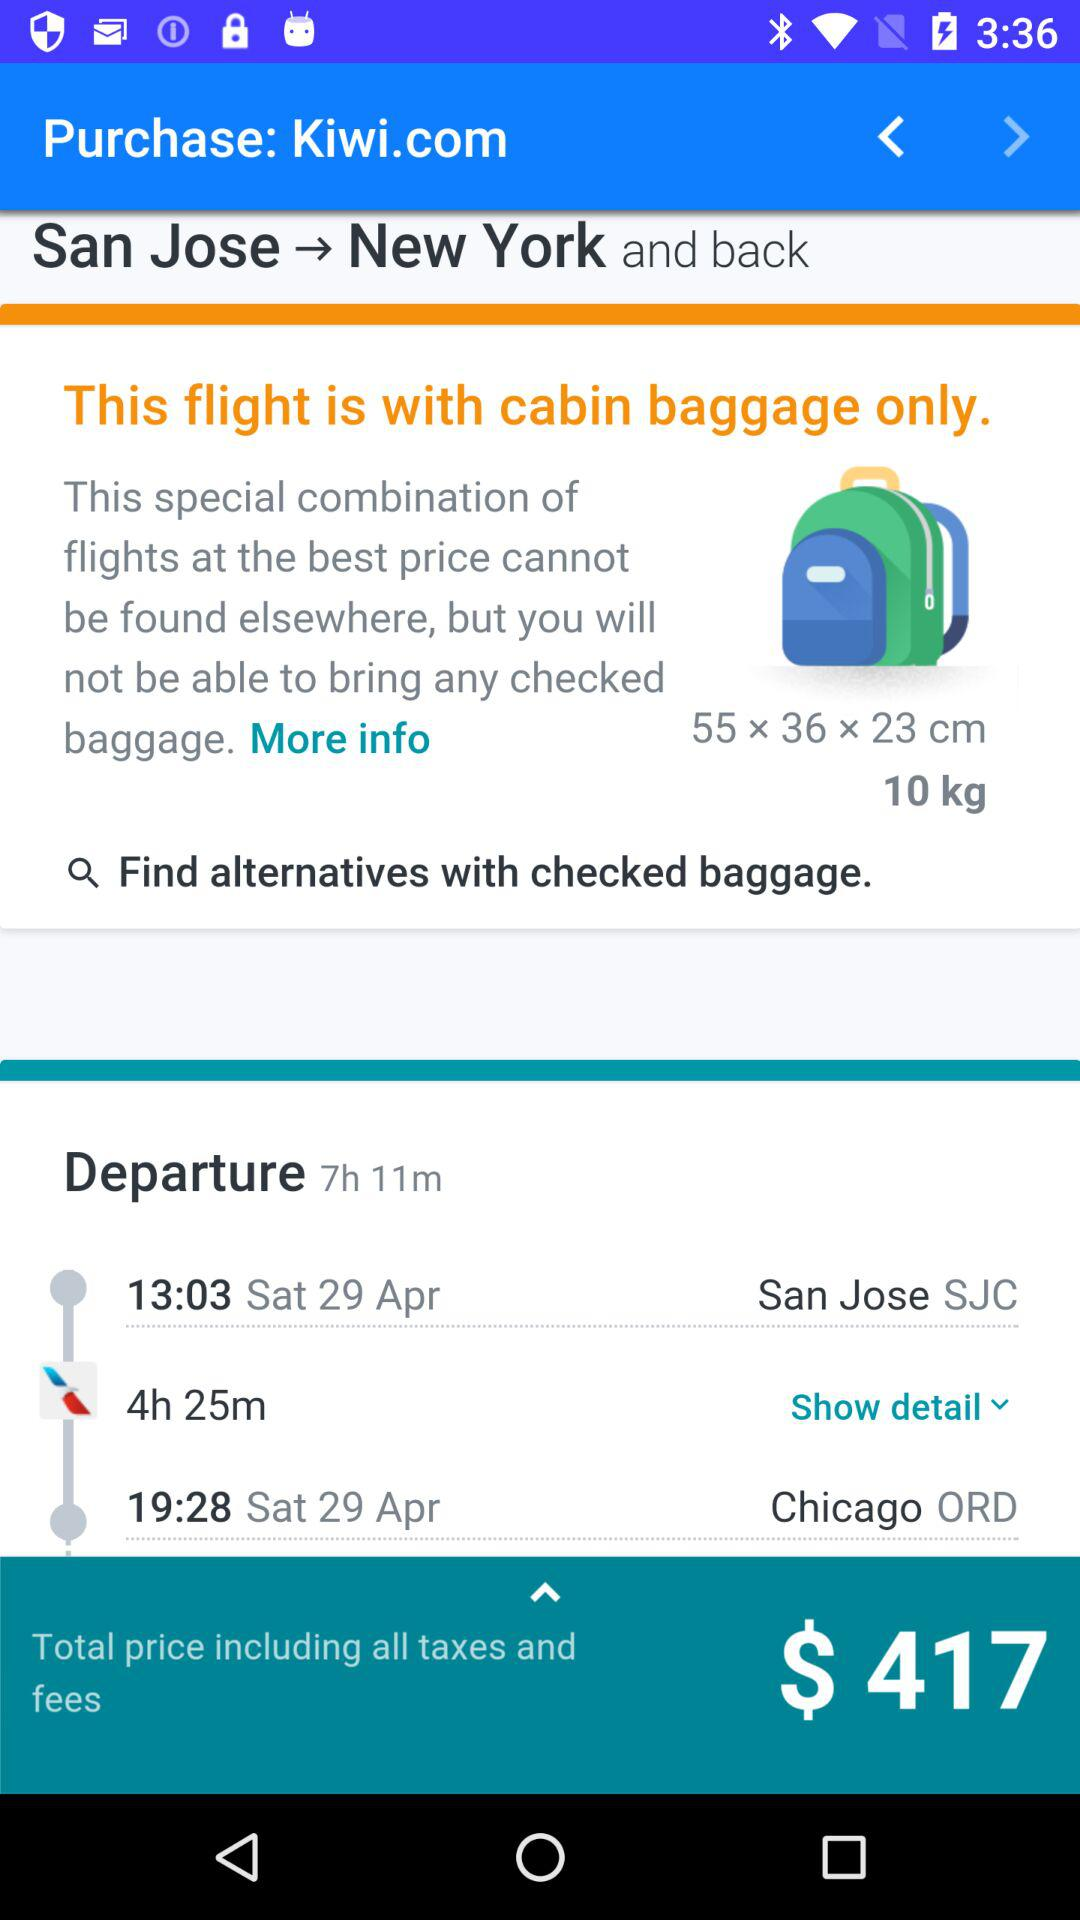How long is the journey? The journey is 4 hours and 25 minutes long. 